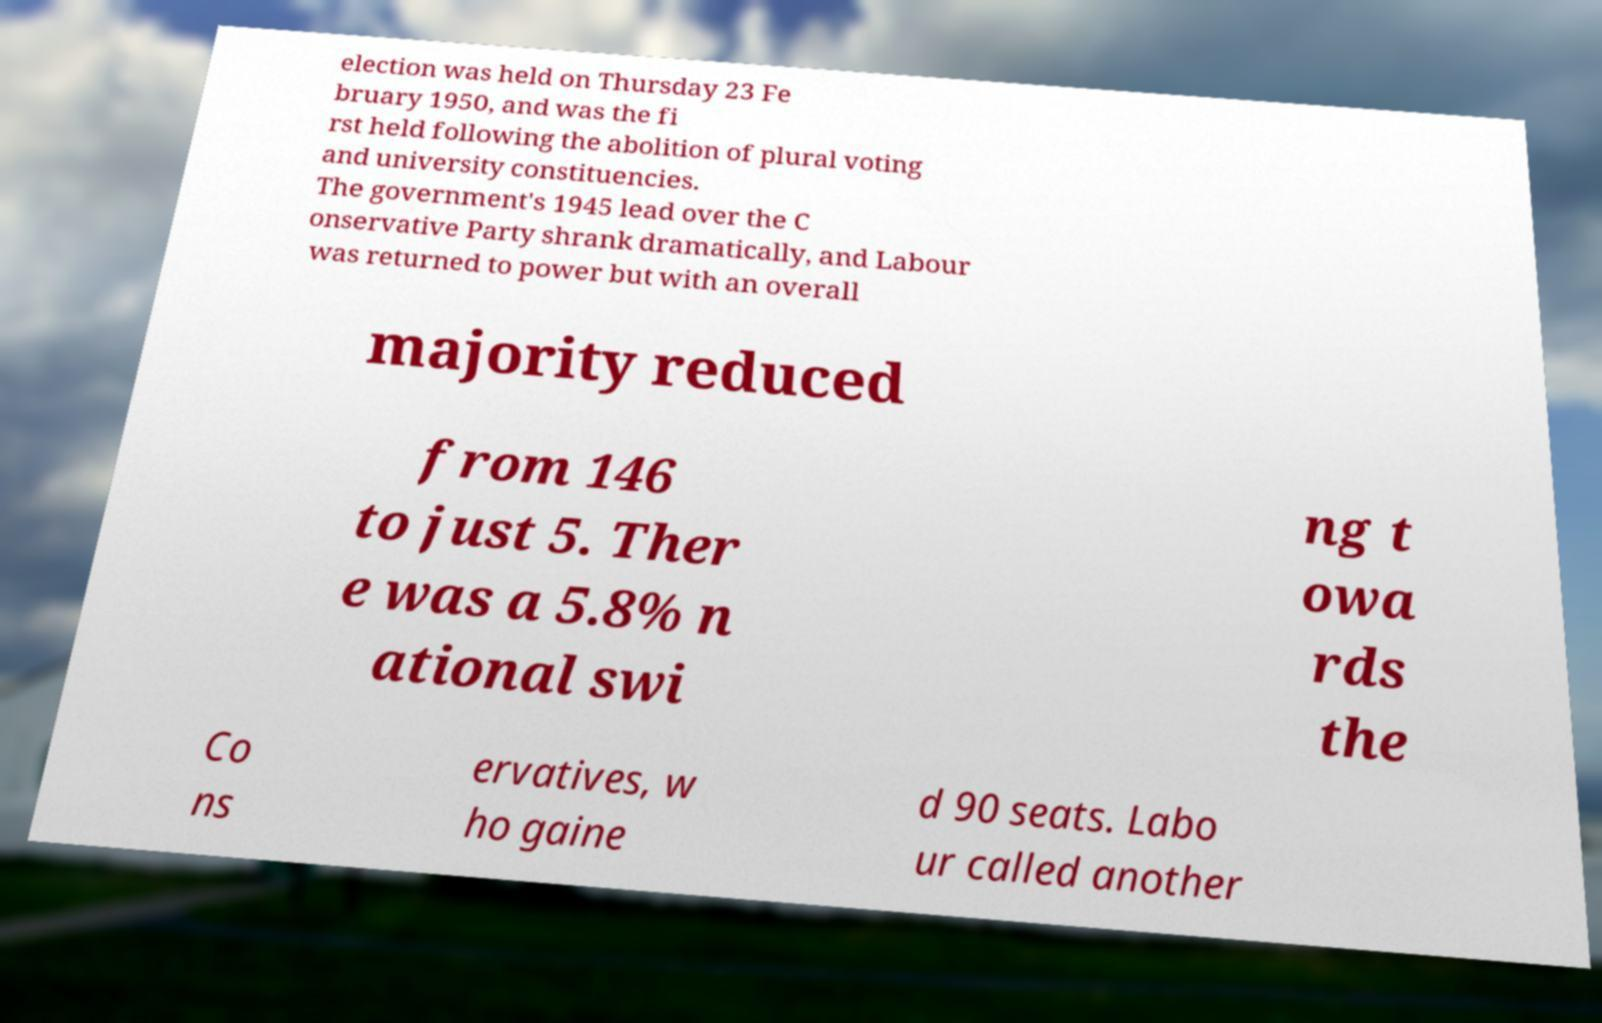Could you assist in decoding the text presented in this image and type it out clearly? election was held on Thursday 23 Fe bruary 1950, and was the fi rst held following the abolition of plural voting and university constituencies. The government's 1945 lead over the C onservative Party shrank dramatically, and Labour was returned to power but with an overall majority reduced from 146 to just 5. Ther e was a 5.8% n ational swi ng t owa rds the Co ns ervatives, w ho gaine d 90 seats. Labo ur called another 